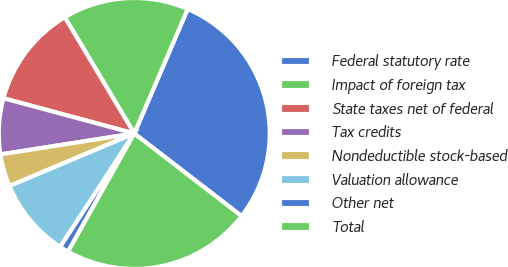<chart> <loc_0><loc_0><loc_500><loc_500><pie_chart><fcel>Federal statutory rate<fcel>Impact of foreign tax<fcel>State taxes net of federal<fcel>Tax credits<fcel>Nondeductible stock-based<fcel>Valuation allowance<fcel>Other net<fcel>Total<nl><fcel>28.99%<fcel>15.03%<fcel>12.24%<fcel>6.66%<fcel>3.87%<fcel>9.45%<fcel>1.08%<fcel>22.69%<nl></chart> 